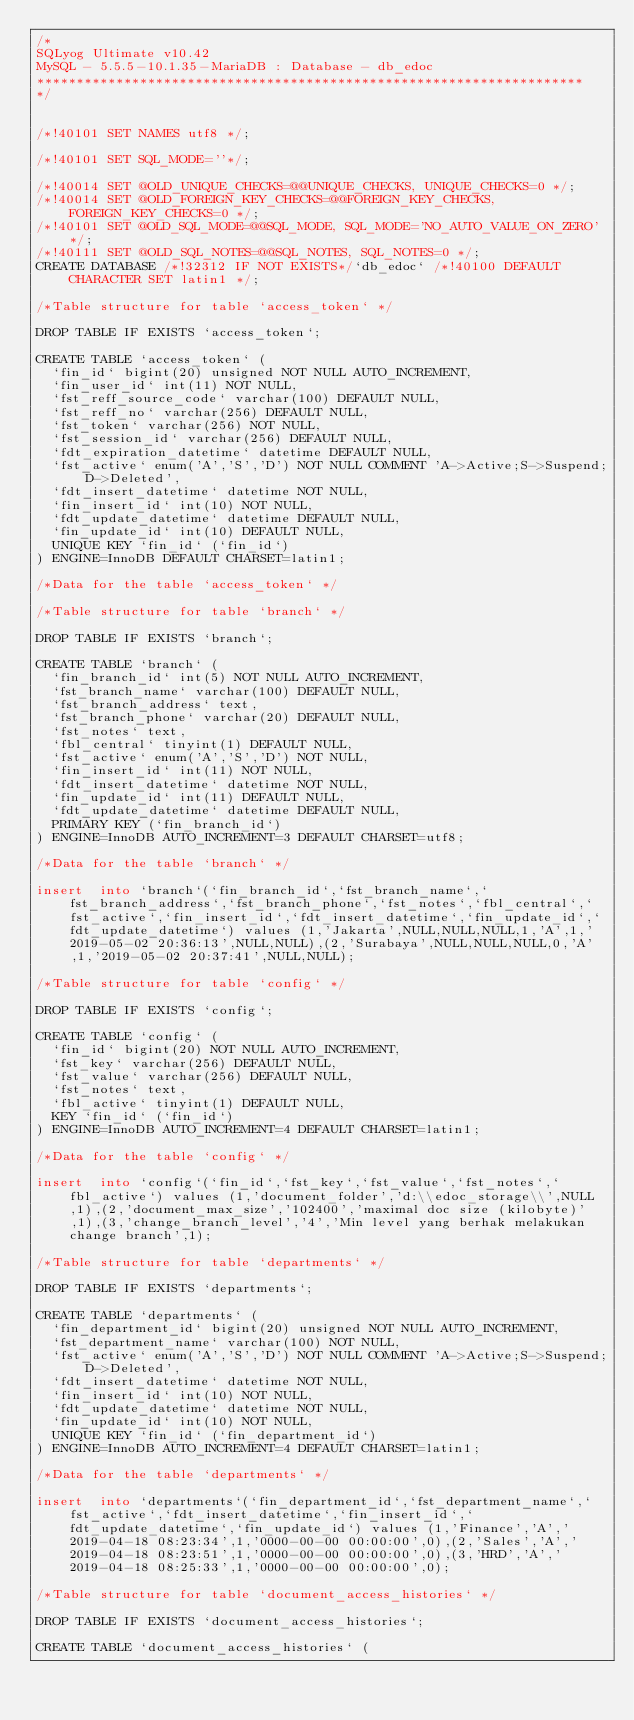<code> <loc_0><loc_0><loc_500><loc_500><_SQL_>/*
SQLyog Ultimate v10.42 
MySQL - 5.5.5-10.1.35-MariaDB : Database - db_edoc
*********************************************************************
*/

/*!40101 SET NAMES utf8 */;

/*!40101 SET SQL_MODE=''*/;

/*!40014 SET @OLD_UNIQUE_CHECKS=@@UNIQUE_CHECKS, UNIQUE_CHECKS=0 */;
/*!40014 SET @OLD_FOREIGN_KEY_CHECKS=@@FOREIGN_KEY_CHECKS, FOREIGN_KEY_CHECKS=0 */;
/*!40101 SET @OLD_SQL_MODE=@@SQL_MODE, SQL_MODE='NO_AUTO_VALUE_ON_ZERO' */;
/*!40111 SET @OLD_SQL_NOTES=@@SQL_NOTES, SQL_NOTES=0 */;
CREATE DATABASE /*!32312 IF NOT EXISTS*/`db_edoc` /*!40100 DEFAULT CHARACTER SET latin1 */;

/*Table structure for table `access_token` */

DROP TABLE IF EXISTS `access_token`;

CREATE TABLE `access_token` (
  `fin_id` bigint(20) unsigned NOT NULL AUTO_INCREMENT,
  `fin_user_id` int(11) NOT NULL,
  `fst_reff_source_code` varchar(100) DEFAULT NULL,
  `fst_reff_no` varchar(256) DEFAULT NULL,
  `fst_token` varchar(256) NOT NULL,
  `fst_session_id` varchar(256) DEFAULT NULL,
  `fdt_expiration_datetime` datetime DEFAULT NULL,
  `fst_active` enum('A','S','D') NOT NULL COMMENT 'A->Active;S->Suspend;D->Deleted',
  `fdt_insert_datetime` datetime NOT NULL,
  `fin_insert_id` int(10) NOT NULL,
  `fdt_update_datetime` datetime DEFAULT NULL,
  `fin_update_id` int(10) DEFAULT NULL,
  UNIQUE KEY `fin_id` (`fin_id`)
) ENGINE=InnoDB DEFAULT CHARSET=latin1;

/*Data for the table `access_token` */

/*Table structure for table `branch` */

DROP TABLE IF EXISTS `branch`;

CREATE TABLE `branch` (
  `fin_branch_id` int(5) NOT NULL AUTO_INCREMENT,
  `fst_branch_name` varchar(100) DEFAULT NULL,
  `fst_branch_address` text,
  `fst_branch_phone` varchar(20) DEFAULT NULL,
  `fst_notes` text,
  `fbl_central` tinyint(1) DEFAULT NULL,
  `fst_active` enum('A','S','D') NOT NULL,
  `fin_insert_id` int(11) NOT NULL,
  `fdt_insert_datetime` datetime NOT NULL,
  `fin_update_id` int(11) DEFAULT NULL,
  `fdt_update_datetime` datetime DEFAULT NULL,
  PRIMARY KEY (`fin_branch_id`)
) ENGINE=InnoDB AUTO_INCREMENT=3 DEFAULT CHARSET=utf8;

/*Data for the table `branch` */

insert  into `branch`(`fin_branch_id`,`fst_branch_name`,`fst_branch_address`,`fst_branch_phone`,`fst_notes`,`fbl_central`,`fst_active`,`fin_insert_id`,`fdt_insert_datetime`,`fin_update_id`,`fdt_update_datetime`) values (1,'Jakarta',NULL,NULL,NULL,1,'A',1,'2019-05-02 20:36:13',NULL,NULL),(2,'Surabaya',NULL,NULL,NULL,0,'A',1,'2019-05-02 20:37:41',NULL,NULL);

/*Table structure for table `config` */

DROP TABLE IF EXISTS `config`;

CREATE TABLE `config` (
  `fin_id` bigint(20) NOT NULL AUTO_INCREMENT,
  `fst_key` varchar(256) DEFAULT NULL,
  `fst_value` varchar(256) DEFAULT NULL,
  `fst_notes` text,
  `fbl_active` tinyint(1) DEFAULT NULL,
  KEY `fin_id` (`fin_id`)
) ENGINE=InnoDB AUTO_INCREMENT=4 DEFAULT CHARSET=latin1;

/*Data for the table `config` */

insert  into `config`(`fin_id`,`fst_key`,`fst_value`,`fst_notes`,`fbl_active`) values (1,'document_folder','d:\\edoc_storage\\',NULL,1),(2,'document_max_size','102400','maximal doc size (kilobyte)',1),(3,'change_branch_level','4','Min level yang berhak melakukan change branch',1);

/*Table structure for table `departments` */

DROP TABLE IF EXISTS `departments`;

CREATE TABLE `departments` (
  `fin_department_id` bigint(20) unsigned NOT NULL AUTO_INCREMENT,
  `fst_department_name` varchar(100) NOT NULL,
  `fst_active` enum('A','S','D') NOT NULL COMMENT 'A->Active;S->Suspend;D->Deleted',
  `fdt_insert_datetime` datetime NOT NULL,
  `fin_insert_id` int(10) NOT NULL,
  `fdt_update_datetime` datetime NOT NULL,
  `fin_update_id` int(10) NOT NULL,
  UNIQUE KEY `fin_id` (`fin_department_id`)
) ENGINE=InnoDB AUTO_INCREMENT=4 DEFAULT CHARSET=latin1;

/*Data for the table `departments` */

insert  into `departments`(`fin_department_id`,`fst_department_name`,`fst_active`,`fdt_insert_datetime`,`fin_insert_id`,`fdt_update_datetime`,`fin_update_id`) values (1,'Finance','A','2019-04-18 08:23:34',1,'0000-00-00 00:00:00',0),(2,'Sales','A','2019-04-18 08:23:51',1,'0000-00-00 00:00:00',0),(3,'HRD','A','2019-04-18 08:25:33',1,'0000-00-00 00:00:00',0);

/*Table structure for table `document_access_histories` */

DROP TABLE IF EXISTS `document_access_histories`;

CREATE TABLE `document_access_histories` (</code> 